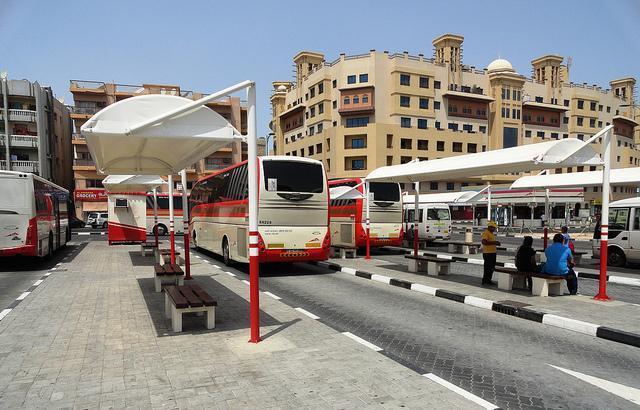How many buses can be seen?
Give a very brief answer. 4. 